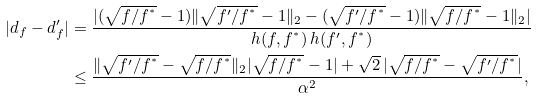<formula> <loc_0><loc_0><loc_500><loc_500>| d _ { f } - d _ { f } ^ { \prime } | & = \frac { | ( \sqrt { f / f ^ { ^ { * } } } - 1 ) \| \sqrt { f ^ { \prime } / f ^ { ^ { * } } } - 1 \| _ { 2 } - ( \sqrt { f ^ { \prime } / f ^ { ^ { * } } } - 1 ) \| \sqrt { f / f ^ { ^ { * } } } - 1 \| _ { 2 } | } { h ( f , f ^ { ^ { * } } ) \, h ( f ^ { \prime } , f ^ { ^ { * } } ) } \\ & \leq \frac { \| \sqrt { f ^ { \prime } / f ^ { ^ { * } } } - \sqrt { f / f ^ { ^ { * } } } \| _ { 2 } | \sqrt { f / f ^ { ^ { * } } } - 1 | + \sqrt { 2 } \, | \sqrt { f / f ^ { ^ { * } } } - \sqrt { f ^ { \prime } / f ^ { ^ { * } } } | } { \alpha ^ { 2 } } ,</formula> 